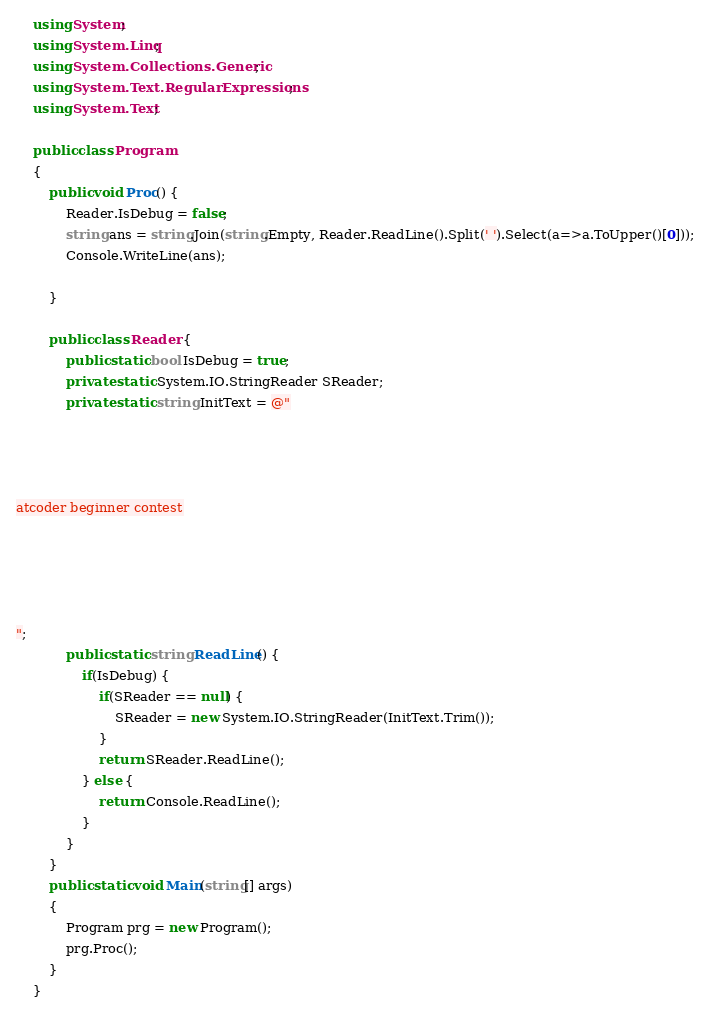<code> <loc_0><loc_0><loc_500><loc_500><_C#_>    using System;
    using System.Linq;
    using System.Collections.Generic;
    using System.Text.RegularExpressions;
    using System.Text;
     
    public class Program
    {
        public void Proc() {
            Reader.IsDebug = false;
            string ans = string.Join(string.Empty, Reader.ReadLine().Split(' ').Select(a=>a.ToUpper()[0]));
            Console.WriteLine(ans);

        }

        public class Reader {
            public static bool IsDebug = true;
            private static System.IO.StringReader SReader;
            private static string InitText = @"




atcoder beginner contest





";
            public static string ReadLine() {
                if(IsDebug) {
                    if(SReader == null) {
                        SReader = new System.IO.StringReader(InitText.Trim());
                    }
                    return SReader.ReadLine();
                } else {
                    return Console.ReadLine();
                }
            }
        }
        public static void Main(string[] args)
        {
            Program prg = new Program();
            prg.Proc();
        }
    }</code> 